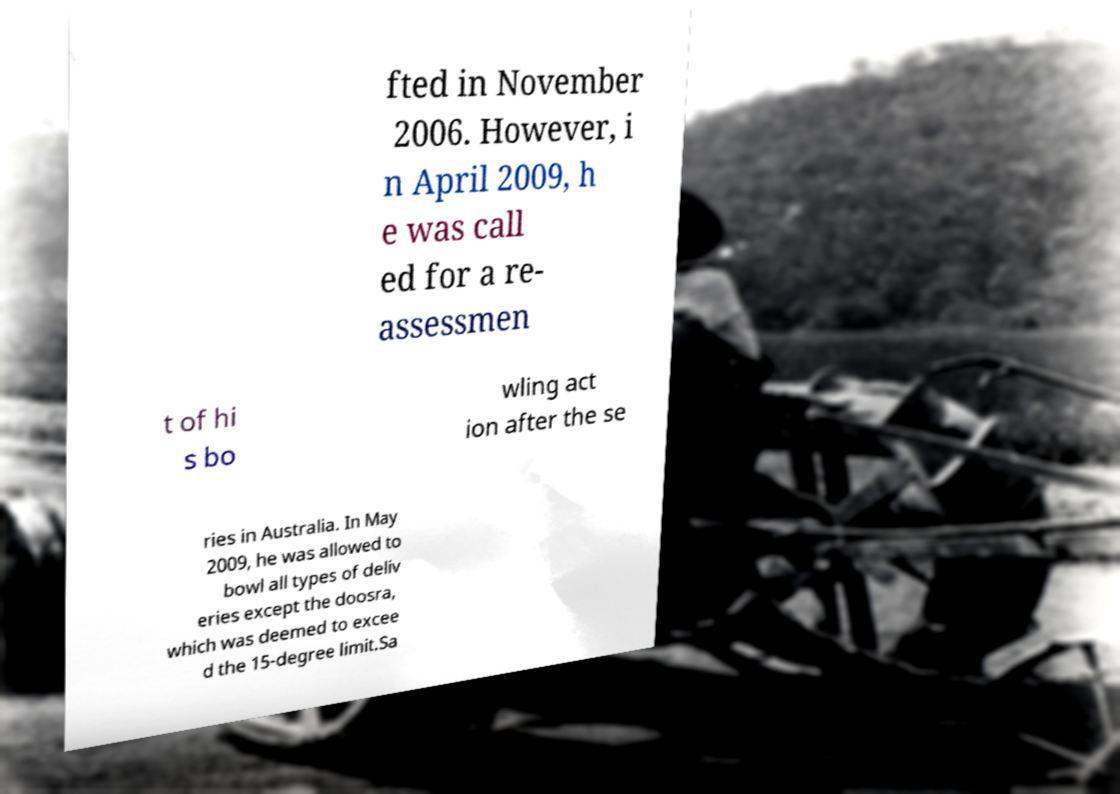Can you read and provide the text displayed in the image?This photo seems to have some interesting text. Can you extract and type it out for me? fted in November 2006. However, i n April 2009, h e was call ed for a re- assessmen t of hi s bo wling act ion after the se ries in Australia. In May 2009, he was allowed to bowl all types of deliv eries except the doosra, which was deemed to excee d the 15-degree limit.Sa 